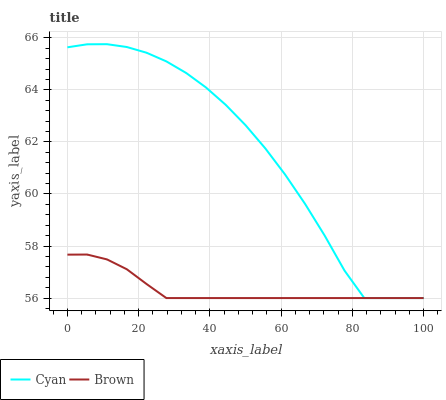Does Brown have the minimum area under the curve?
Answer yes or no. Yes. Does Cyan have the maximum area under the curve?
Answer yes or no. Yes. Does Brown have the maximum area under the curve?
Answer yes or no. No. Is Brown the smoothest?
Answer yes or no. Yes. Is Cyan the roughest?
Answer yes or no. Yes. Is Brown the roughest?
Answer yes or no. No. Does Cyan have the lowest value?
Answer yes or no. Yes. Does Cyan have the highest value?
Answer yes or no. Yes. Does Brown have the highest value?
Answer yes or no. No. Does Cyan intersect Brown?
Answer yes or no. Yes. Is Cyan less than Brown?
Answer yes or no. No. Is Cyan greater than Brown?
Answer yes or no. No. 